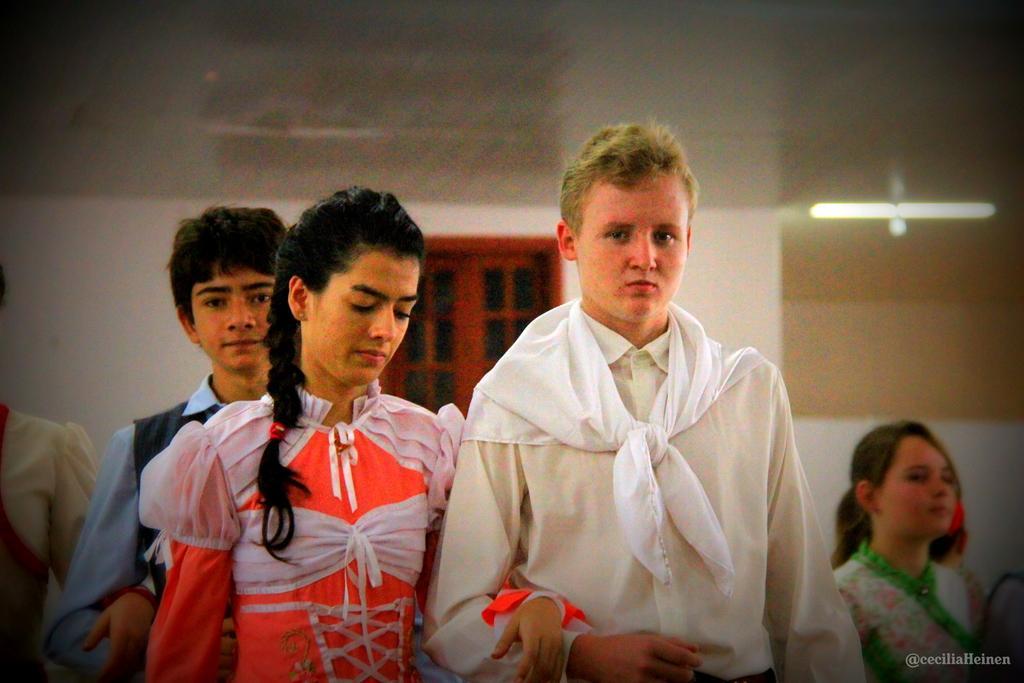Describe this image in one or two sentences. At the bottom of this image, there are persons in different colored dresses. On the bottom right, there is a watermark. In the background, there is a window, a light and a wall. 